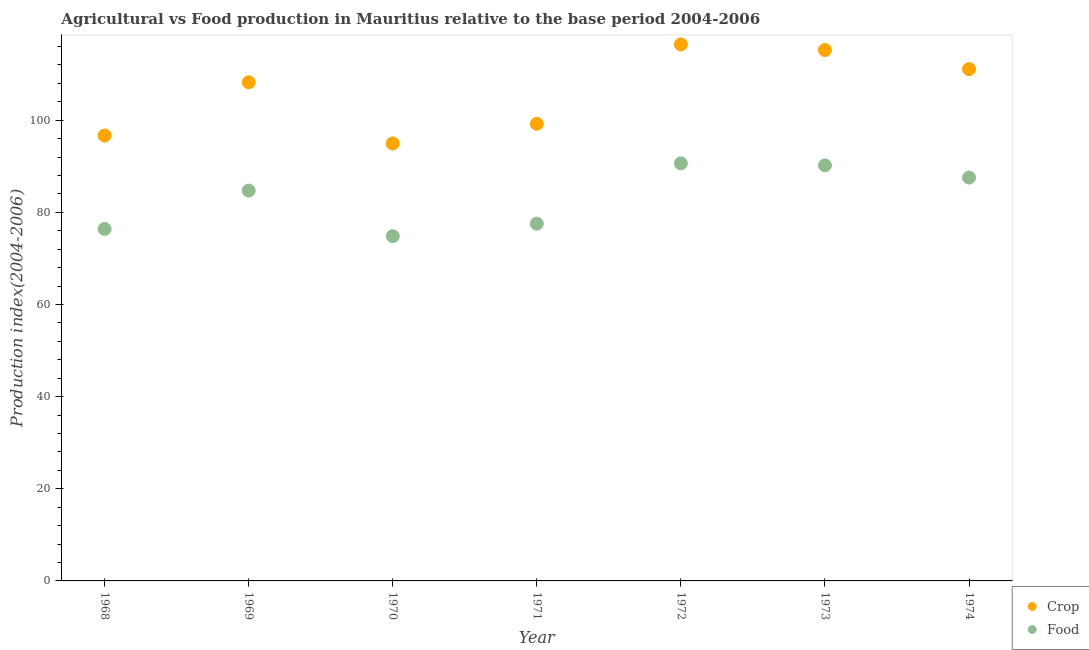How many different coloured dotlines are there?
Ensure brevity in your answer.  2. Is the number of dotlines equal to the number of legend labels?
Keep it short and to the point. Yes. What is the food production index in 1970?
Provide a succinct answer. 74.82. Across all years, what is the maximum food production index?
Your response must be concise. 90.63. Across all years, what is the minimum food production index?
Your answer should be compact. 74.82. In which year was the food production index maximum?
Keep it short and to the point. 1972. What is the total crop production index in the graph?
Your response must be concise. 741.76. What is the difference between the food production index in 1971 and that in 1972?
Provide a short and direct response. -13.09. What is the difference between the crop production index in 1972 and the food production index in 1971?
Keep it short and to the point. 38.89. What is the average food production index per year?
Your answer should be very brief. 83.12. In the year 1969, what is the difference between the food production index and crop production index?
Provide a succinct answer. -23.5. What is the ratio of the food production index in 1970 to that in 1973?
Keep it short and to the point. 0.83. Is the food production index in 1968 less than that in 1971?
Offer a terse response. Yes. Is the difference between the food production index in 1972 and 1973 greater than the difference between the crop production index in 1972 and 1973?
Make the answer very short. No. What is the difference between the highest and the second highest food production index?
Provide a short and direct response. 0.44. What is the difference between the highest and the lowest food production index?
Your answer should be very brief. 15.81. In how many years, is the food production index greater than the average food production index taken over all years?
Ensure brevity in your answer.  4. Is the crop production index strictly greater than the food production index over the years?
Give a very brief answer. Yes. Is the crop production index strictly less than the food production index over the years?
Provide a succinct answer. No. How many dotlines are there?
Offer a very short reply. 2. How many years are there in the graph?
Your answer should be very brief. 7. How many legend labels are there?
Your response must be concise. 2. What is the title of the graph?
Your answer should be compact. Agricultural vs Food production in Mauritius relative to the base period 2004-2006. What is the label or title of the Y-axis?
Provide a succinct answer. Production index(2004-2006). What is the Production index(2004-2006) in Crop in 1968?
Offer a very short reply. 96.66. What is the Production index(2004-2006) in Food in 1968?
Give a very brief answer. 76.39. What is the Production index(2004-2006) in Crop in 1969?
Provide a short and direct response. 108.22. What is the Production index(2004-2006) of Food in 1969?
Your answer should be very brief. 84.72. What is the Production index(2004-2006) of Crop in 1970?
Ensure brevity in your answer.  94.94. What is the Production index(2004-2006) in Food in 1970?
Your answer should be very brief. 74.82. What is the Production index(2004-2006) in Crop in 1971?
Ensure brevity in your answer.  99.21. What is the Production index(2004-2006) of Food in 1971?
Offer a terse response. 77.54. What is the Production index(2004-2006) of Crop in 1972?
Your answer should be compact. 116.43. What is the Production index(2004-2006) in Food in 1972?
Make the answer very short. 90.63. What is the Production index(2004-2006) of Crop in 1973?
Your response must be concise. 115.22. What is the Production index(2004-2006) in Food in 1973?
Offer a terse response. 90.19. What is the Production index(2004-2006) of Crop in 1974?
Provide a short and direct response. 111.08. What is the Production index(2004-2006) of Food in 1974?
Make the answer very short. 87.54. Across all years, what is the maximum Production index(2004-2006) of Crop?
Give a very brief answer. 116.43. Across all years, what is the maximum Production index(2004-2006) of Food?
Offer a terse response. 90.63. Across all years, what is the minimum Production index(2004-2006) of Crop?
Make the answer very short. 94.94. Across all years, what is the minimum Production index(2004-2006) in Food?
Provide a short and direct response. 74.82. What is the total Production index(2004-2006) in Crop in the graph?
Ensure brevity in your answer.  741.76. What is the total Production index(2004-2006) of Food in the graph?
Give a very brief answer. 581.83. What is the difference between the Production index(2004-2006) of Crop in 1968 and that in 1969?
Provide a short and direct response. -11.56. What is the difference between the Production index(2004-2006) in Food in 1968 and that in 1969?
Give a very brief answer. -8.33. What is the difference between the Production index(2004-2006) of Crop in 1968 and that in 1970?
Ensure brevity in your answer.  1.72. What is the difference between the Production index(2004-2006) of Food in 1968 and that in 1970?
Your answer should be compact. 1.57. What is the difference between the Production index(2004-2006) in Crop in 1968 and that in 1971?
Provide a succinct answer. -2.55. What is the difference between the Production index(2004-2006) in Food in 1968 and that in 1971?
Offer a very short reply. -1.15. What is the difference between the Production index(2004-2006) in Crop in 1968 and that in 1972?
Keep it short and to the point. -19.77. What is the difference between the Production index(2004-2006) in Food in 1968 and that in 1972?
Provide a succinct answer. -14.24. What is the difference between the Production index(2004-2006) of Crop in 1968 and that in 1973?
Provide a short and direct response. -18.56. What is the difference between the Production index(2004-2006) of Crop in 1968 and that in 1974?
Offer a very short reply. -14.42. What is the difference between the Production index(2004-2006) of Food in 1968 and that in 1974?
Your response must be concise. -11.15. What is the difference between the Production index(2004-2006) in Crop in 1969 and that in 1970?
Offer a very short reply. 13.28. What is the difference between the Production index(2004-2006) in Crop in 1969 and that in 1971?
Ensure brevity in your answer.  9.01. What is the difference between the Production index(2004-2006) in Food in 1969 and that in 1971?
Make the answer very short. 7.18. What is the difference between the Production index(2004-2006) in Crop in 1969 and that in 1972?
Provide a succinct answer. -8.21. What is the difference between the Production index(2004-2006) of Food in 1969 and that in 1972?
Your answer should be compact. -5.91. What is the difference between the Production index(2004-2006) of Food in 1969 and that in 1973?
Provide a succinct answer. -5.47. What is the difference between the Production index(2004-2006) in Crop in 1969 and that in 1974?
Make the answer very short. -2.86. What is the difference between the Production index(2004-2006) of Food in 1969 and that in 1974?
Keep it short and to the point. -2.82. What is the difference between the Production index(2004-2006) in Crop in 1970 and that in 1971?
Provide a succinct answer. -4.27. What is the difference between the Production index(2004-2006) in Food in 1970 and that in 1971?
Your response must be concise. -2.72. What is the difference between the Production index(2004-2006) of Crop in 1970 and that in 1972?
Provide a succinct answer. -21.49. What is the difference between the Production index(2004-2006) in Food in 1970 and that in 1972?
Offer a very short reply. -15.81. What is the difference between the Production index(2004-2006) in Crop in 1970 and that in 1973?
Provide a short and direct response. -20.28. What is the difference between the Production index(2004-2006) in Food in 1970 and that in 1973?
Give a very brief answer. -15.37. What is the difference between the Production index(2004-2006) of Crop in 1970 and that in 1974?
Ensure brevity in your answer.  -16.14. What is the difference between the Production index(2004-2006) of Food in 1970 and that in 1974?
Give a very brief answer. -12.72. What is the difference between the Production index(2004-2006) of Crop in 1971 and that in 1972?
Provide a succinct answer. -17.22. What is the difference between the Production index(2004-2006) of Food in 1971 and that in 1972?
Give a very brief answer. -13.09. What is the difference between the Production index(2004-2006) in Crop in 1971 and that in 1973?
Provide a succinct answer. -16.01. What is the difference between the Production index(2004-2006) in Food in 1971 and that in 1973?
Keep it short and to the point. -12.65. What is the difference between the Production index(2004-2006) of Crop in 1971 and that in 1974?
Your response must be concise. -11.87. What is the difference between the Production index(2004-2006) in Crop in 1972 and that in 1973?
Offer a very short reply. 1.21. What is the difference between the Production index(2004-2006) of Food in 1972 and that in 1973?
Give a very brief answer. 0.44. What is the difference between the Production index(2004-2006) of Crop in 1972 and that in 1974?
Make the answer very short. 5.35. What is the difference between the Production index(2004-2006) in Food in 1972 and that in 1974?
Offer a very short reply. 3.09. What is the difference between the Production index(2004-2006) of Crop in 1973 and that in 1974?
Keep it short and to the point. 4.14. What is the difference between the Production index(2004-2006) of Food in 1973 and that in 1974?
Give a very brief answer. 2.65. What is the difference between the Production index(2004-2006) of Crop in 1968 and the Production index(2004-2006) of Food in 1969?
Offer a very short reply. 11.94. What is the difference between the Production index(2004-2006) of Crop in 1968 and the Production index(2004-2006) of Food in 1970?
Ensure brevity in your answer.  21.84. What is the difference between the Production index(2004-2006) in Crop in 1968 and the Production index(2004-2006) in Food in 1971?
Give a very brief answer. 19.12. What is the difference between the Production index(2004-2006) in Crop in 1968 and the Production index(2004-2006) in Food in 1972?
Offer a very short reply. 6.03. What is the difference between the Production index(2004-2006) of Crop in 1968 and the Production index(2004-2006) of Food in 1973?
Offer a very short reply. 6.47. What is the difference between the Production index(2004-2006) of Crop in 1968 and the Production index(2004-2006) of Food in 1974?
Offer a terse response. 9.12. What is the difference between the Production index(2004-2006) of Crop in 1969 and the Production index(2004-2006) of Food in 1970?
Your answer should be compact. 33.4. What is the difference between the Production index(2004-2006) of Crop in 1969 and the Production index(2004-2006) of Food in 1971?
Your answer should be very brief. 30.68. What is the difference between the Production index(2004-2006) in Crop in 1969 and the Production index(2004-2006) in Food in 1972?
Your answer should be very brief. 17.59. What is the difference between the Production index(2004-2006) of Crop in 1969 and the Production index(2004-2006) of Food in 1973?
Make the answer very short. 18.03. What is the difference between the Production index(2004-2006) in Crop in 1969 and the Production index(2004-2006) in Food in 1974?
Ensure brevity in your answer.  20.68. What is the difference between the Production index(2004-2006) of Crop in 1970 and the Production index(2004-2006) of Food in 1971?
Keep it short and to the point. 17.4. What is the difference between the Production index(2004-2006) of Crop in 1970 and the Production index(2004-2006) of Food in 1972?
Ensure brevity in your answer.  4.31. What is the difference between the Production index(2004-2006) in Crop in 1970 and the Production index(2004-2006) in Food in 1973?
Keep it short and to the point. 4.75. What is the difference between the Production index(2004-2006) of Crop in 1970 and the Production index(2004-2006) of Food in 1974?
Make the answer very short. 7.4. What is the difference between the Production index(2004-2006) of Crop in 1971 and the Production index(2004-2006) of Food in 1972?
Make the answer very short. 8.58. What is the difference between the Production index(2004-2006) in Crop in 1971 and the Production index(2004-2006) in Food in 1973?
Make the answer very short. 9.02. What is the difference between the Production index(2004-2006) of Crop in 1971 and the Production index(2004-2006) of Food in 1974?
Your answer should be compact. 11.67. What is the difference between the Production index(2004-2006) of Crop in 1972 and the Production index(2004-2006) of Food in 1973?
Make the answer very short. 26.24. What is the difference between the Production index(2004-2006) in Crop in 1972 and the Production index(2004-2006) in Food in 1974?
Offer a terse response. 28.89. What is the difference between the Production index(2004-2006) in Crop in 1973 and the Production index(2004-2006) in Food in 1974?
Provide a short and direct response. 27.68. What is the average Production index(2004-2006) in Crop per year?
Keep it short and to the point. 105.97. What is the average Production index(2004-2006) in Food per year?
Offer a terse response. 83.12. In the year 1968, what is the difference between the Production index(2004-2006) in Crop and Production index(2004-2006) in Food?
Ensure brevity in your answer.  20.27. In the year 1969, what is the difference between the Production index(2004-2006) of Crop and Production index(2004-2006) of Food?
Make the answer very short. 23.5. In the year 1970, what is the difference between the Production index(2004-2006) in Crop and Production index(2004-2006) in Food?
Your response must be concise. 20.12. In the year 1971, what is the difference between the Production index(2004-2006) in Crop and Production index(2004-2006) in Food?
Provide a succinct answer. 21.67. In the year 1972, what is the difference between the Production index(2004-2006) of Crop and Production index(2004-2006) of Food?
Give a very brief answer. 25.8. In the year 1973, what is the difference between the Production index(2004-2006) in Crop and Production index(2004-2006) in Food?
Provide a succinct answer. 25.03. In the year 1974, what is the difference between the Production index(2004-2006) of Crop and Production index(2004-2006) of Food?
Your response must be concise. 23.54. What is the ratio of the Production index(2004-2006) in Crop in 1968 to that in 1969?
Provide a succinct answer. 0.89. What is the ratio of the Production index(2004-2006) of Food in 1968 to that in 1969?
Your answer should be very brief. 0.9. What is the ratio of the Production index(2004-2006) of Crop in 1968 to that in 1970?
Make the answer very short. 1.02. What is the ratio of the Production index(2004-2006) in Food in 1968 to that in 1970?
Your answer should be very brief. 1.02. What is the ratio of the Production index(2004-2006) of Crop in 1968 to that in 1971?
Your response must be concise. 0.97. What is the ratio of the Production index(2004-2006) of Food in 1968 to that in 1971?
Provide a short and direct response. 0.99. What is the ratio of the Production index(2004-2006) of Crop in 1968 to that in 1972?
Give a very brief answer. 0.83. What is the ratio of the Production index(2004-2006) of Food in 1968 to that in 1972?
Offer a terse response. 0.84. What is the ratio of the Production index(2004-2006) in Crop in 1968 to that in 1973?
Offer a terse response. 0.84. What is the ratio of the Production index(2004-2006) of Food in 1968 to that in 1973?
Your answer should be very brief. 0.85. What is the ratio of the Production index(2004-2006) in Crop in 1968 to that in 1974?
Offer a very short reply. 0.87. What is the ratio of the Production index(2004-2006) of Food in 1968 to that in 1974?
Your response must be concise. 0.87. What is the ratio of the Production index(2004-2006) in Crop in 1969 to that in 1970?
Ensure brevity in your answer.  1.14. What is the ratio of the Production index(2004-2006) in Food in 1969 to that in 1970?
Keep it short and to the point. 1.13. What is the ratio of the Production index(2004-2006) in Crop in 1969 to that in 1971?
Give a very brief answer. 1.09. What is the ratio of the Production index(2004-2006) of Food in 1969 to that in 1971?
Give a very brief answer. 1.09. What is the ratio of the Production index(2004-2006) of Crop in 1969 to that in 1972?
Offer a very short reply. 0.93. What is the ratio of the Production index(2004-2006) of Food in 1969 to that in 1972?
Your answer should be compact. 0.93. What is the ratio of the Production index(2004-2006) in Crop in 1969 to that in 1973?
Provide a short and direct response. 0.94. What is the ratio of the Production index(2004-2006) of Food in 1969 to that in 1973?
Provide a short and direct response. 0.94. What is the ratio of the Production index(2004-2006) of Crop in 1969 to that in 1974?
Your answer should be very brief. 0.97. What is the ratio of the Production index(2004-2006) in Food in 1969 to that in 1974?
Ensure brevity in your answer.  0.97. What is the ratio of the Production index(2004-2006) of Crop in 1970 to that in 1971?
Keep it short and to the point. 0.96. What is the ratio of the Production index(2004-2006) of Food in 1970 to that in 1971?
Your answer should be very brief. 0.96. What is the ratio of the Production index(2004-2006) of Crop in 1970 to that in 1972?
Your answer should be compact. 0.82. What is the ratio of the Production index(2004-2006) of Food in 1970 to that in 1972?
Ensure brevity in your answer.  0.83. What is the ratio of the Production index(2004-2006) of Crop in 1970 to that in 1973?
Your answer should be very brief. 0.82. What is the ratio of the Production index(2004-2006) in Food in 1970 to that in 1973?
Provide a short and direct response. 0.83. What is the ratio of the Production index(2004-2006) of Crop in 1970 to that in 1974?
Offer a terse response. 0.85. What is the ratio of the Production index(2004-2006) of Food in 1970 to that in 1974?
Provide a succinct answer. 0.85. What is the ratio of the Production index(2004-2006) of Crop in 1971 to that in 1972?
Ensure brevity in your answer.  0.85. What is the ratio of the Production index(2004-2006) of Food in 1971 to that in 1972?
Offer a terse response. 0.86. What is the ratio of the Production index(2004-2006) of Crop in 1971 to that in 1973?
Keep it short and to the point. 0.86. What is the ratio of the Production index(2004-2006) of Food in 1971 to that in 1973?
Make the answer very short. 0.86. What is the ratio of the Production index(2004-2006) of Crop in 1971 to that in 1974?
Keep it short and to the point. 0.89. What is the ratio of the Production index(2004-2006) of Food in 1971 to that in 1974?
Provide a succinct answer. 0.89. What is the ratio of the Production index(2004-2006) of Crop in 1972 to that in 1973?
Provide a short and direct response. 1.01. What is the ratio of the Production index(2004-2006) of Food in 1972 to that in 1973?
Offer a very short reply. 1. What is the ratio of the Production index(2004-2006) of Crop in 1972 to that in 1974?
Offer a very short reply. 1.05. What is the ratio of the Production index(2004-2006) in Food in 1972 to that in 1974?
Your answer should be very brief. 1.04. What is the ratio of the Production index(2004-2006) in Crop in 1973 to that in 1974?
Offer a very short reply. 1.04. What is the ratio of the Production index(2004-2006) of Food in 1973 to that in 1974?
Your answer should be compact. 1.03. What is the difference between the highest and the second highest Production index(2004-2006) in Crop?
Offer a very short reply. 1.21. What is the difference between the highest and the second highest Production index(2004-2006) in Food?
Provide a short and direct response. 0.44. What is the difference between the highest and the lowest Production index(2004-2006) of Crop?
Your answer should be compact. 21.49. What is the difference between the highest and the lowest Production index(2004-2006) of Food?
Make the answer very short. 15.81. 